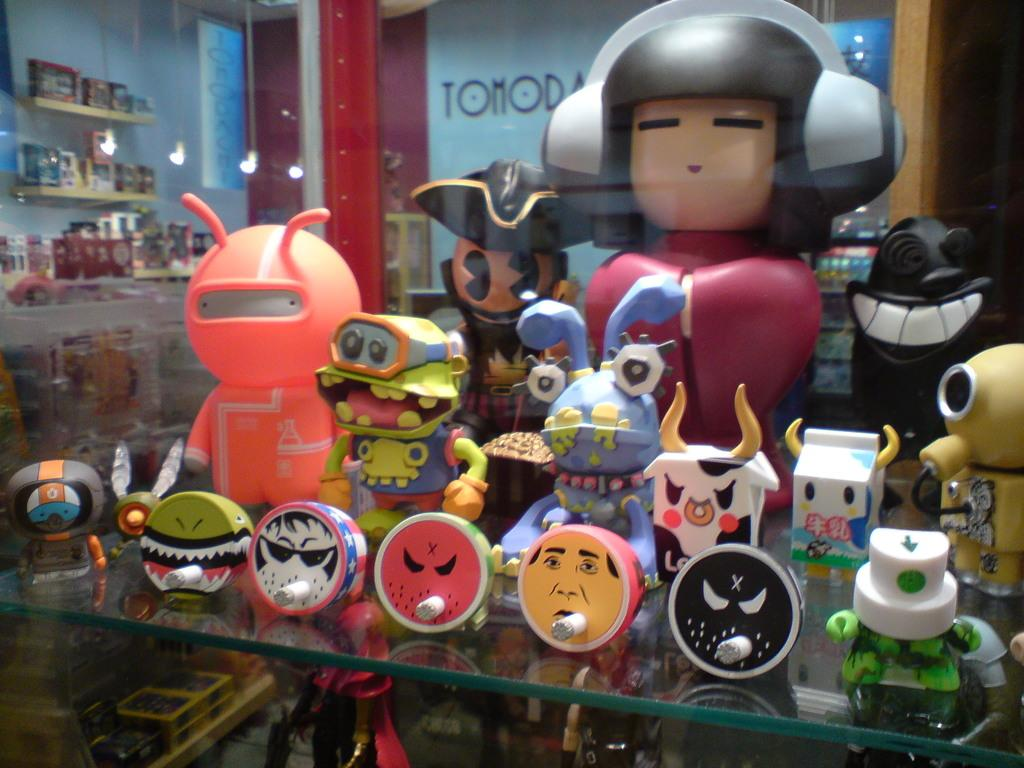What is located on the table in the center of the image? There are toys placed on a table in the center of the image. Can you describe the toys visible in the background of the image? There are toys visible in the background of the image. What can be seen in the background of the image besides the toys? There is a wall in the background of the image. What type of thunder can be heard in the image? There is no thunder present in the image, as it is a still image and does not contain any sound. 